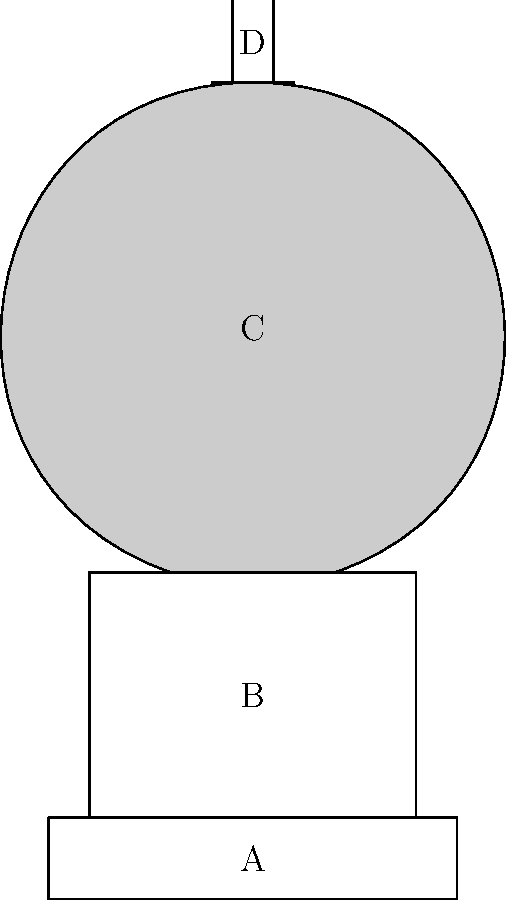Based on the simplified cross-section diagram of the Statue of Liberty's internal structure, which part of the statue is most likely to contain the main spiral staircase leading to the crown? To answer this question, let's analyze the diagram step-by-step:

1. The diagram shows a simplified cross-section of the Statue of Liberty with four main sections labeled A, B, C, and D.

2. Section A represents the base of the statue, which is typically solid and used for foundational support.

3. Section B represents the pedestal, which often contains exhibit spaces and the beginning of the ascent, but is usually too wide for the main spiral staircase.

4. Section C represents the main body of the statue. This is the tallest and most narrow part of the structure, making it the ideal location for a spiral staircase.

5. Section D represents the crown of the statue, which is the destination for visitors climbing the stairs but is too small to contain the main staircase itself.

6. Given the height and relatively narrow width of section C, it provides the most suitable space for a spiral staircase that would allow visitors to ascend from the pedestal to the crown.

Therefore, the main spiral staircase is most likely located in section C, the main body of the statue.
Answer: Section C (main body) 